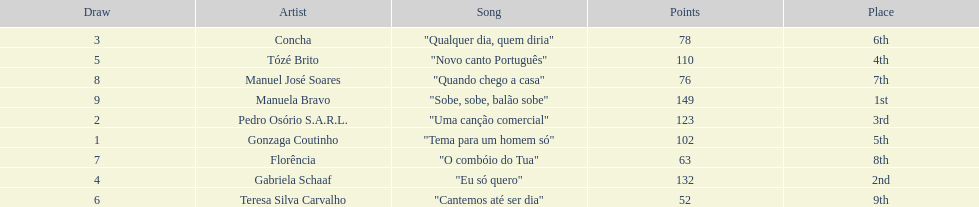Who was the last draw? Manuela Bravo. 